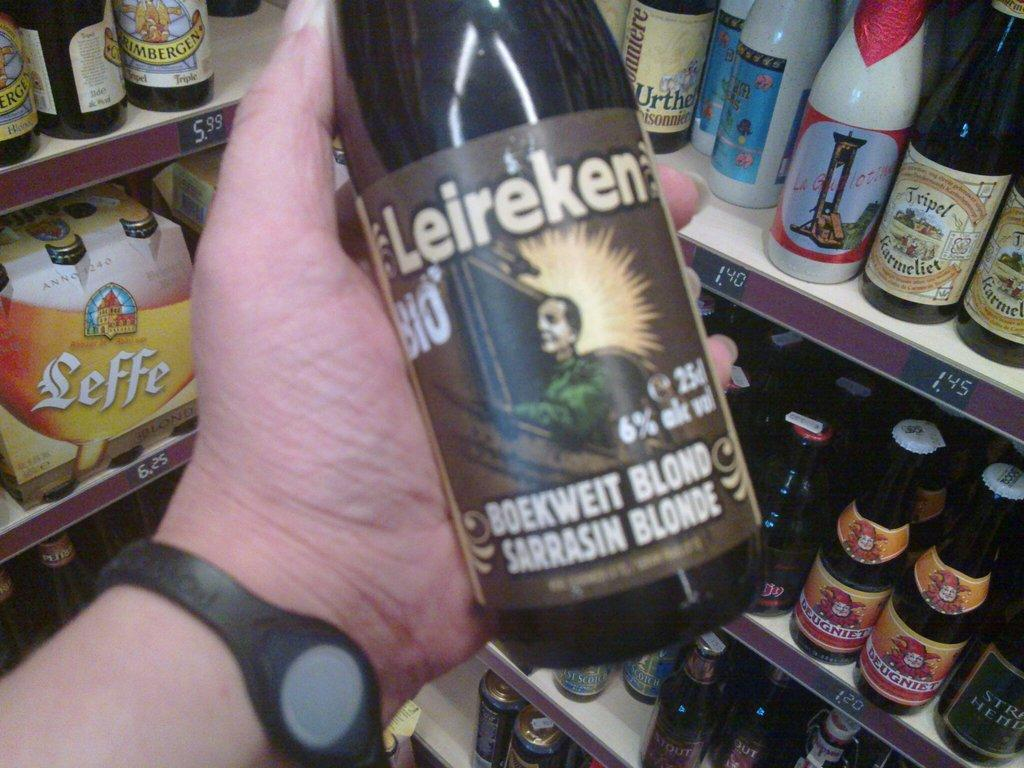<image>
Offer a succinct explanation of the picture presented. Leireken is being held in the owners hand while standing in a storage area with other spirits. 